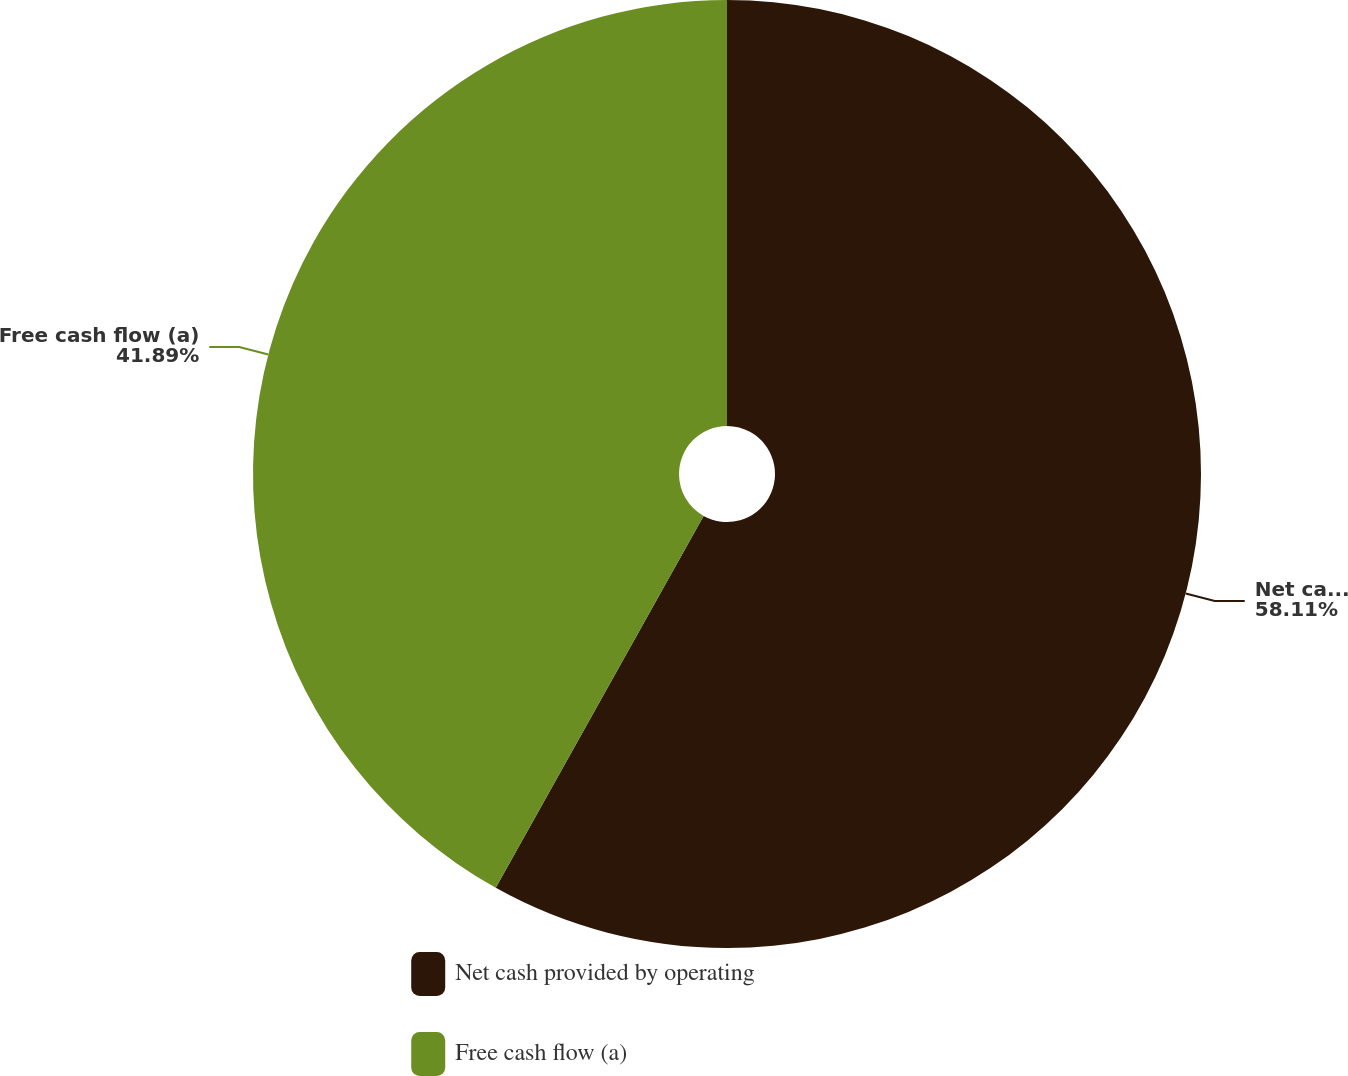Convert chart to OTSL. <chart><loc_0><loc_0><loc_500><loc_500><pie_chart><fcel>Net cash provided by operating<fcel>Free cash flow (a)<nl><fcel>58.11%<fcel>41.89%<nl></chart> 